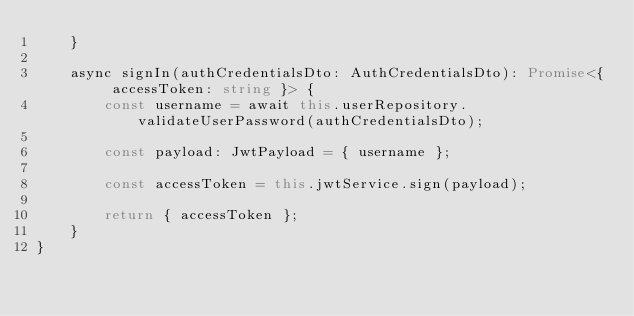<code> <loc_0><loc_0><loc_500><loc_500><_TypeScript_>    }

    async signIn(authCredentialsDto: AuthCredentialsDto): Promise<{ accessToken: string }> {
        const username = await this.userRepository.validateUserPassword(authCredentialsDto);

        const payload: JwtPayload = { username };

        const accessToken = this.jwtService.sign(payload);

        return { accessToken };
    }
}
</code> 